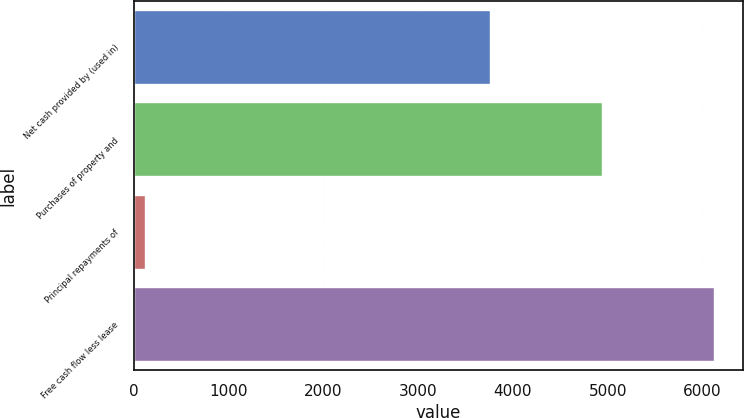Convert chart to OTSL. <chart><loc_0><loc_0><loc_500><loc_500><bar_chart><fcel>Net cash provided by (used in)<fcel>Purchases of property and<fcel>Principal repayments of<fcel>Free cash flow less lease<nl><fcel>3763<fcel>4942.9<fcel>121<fcel>6122.8<nl></chart> 